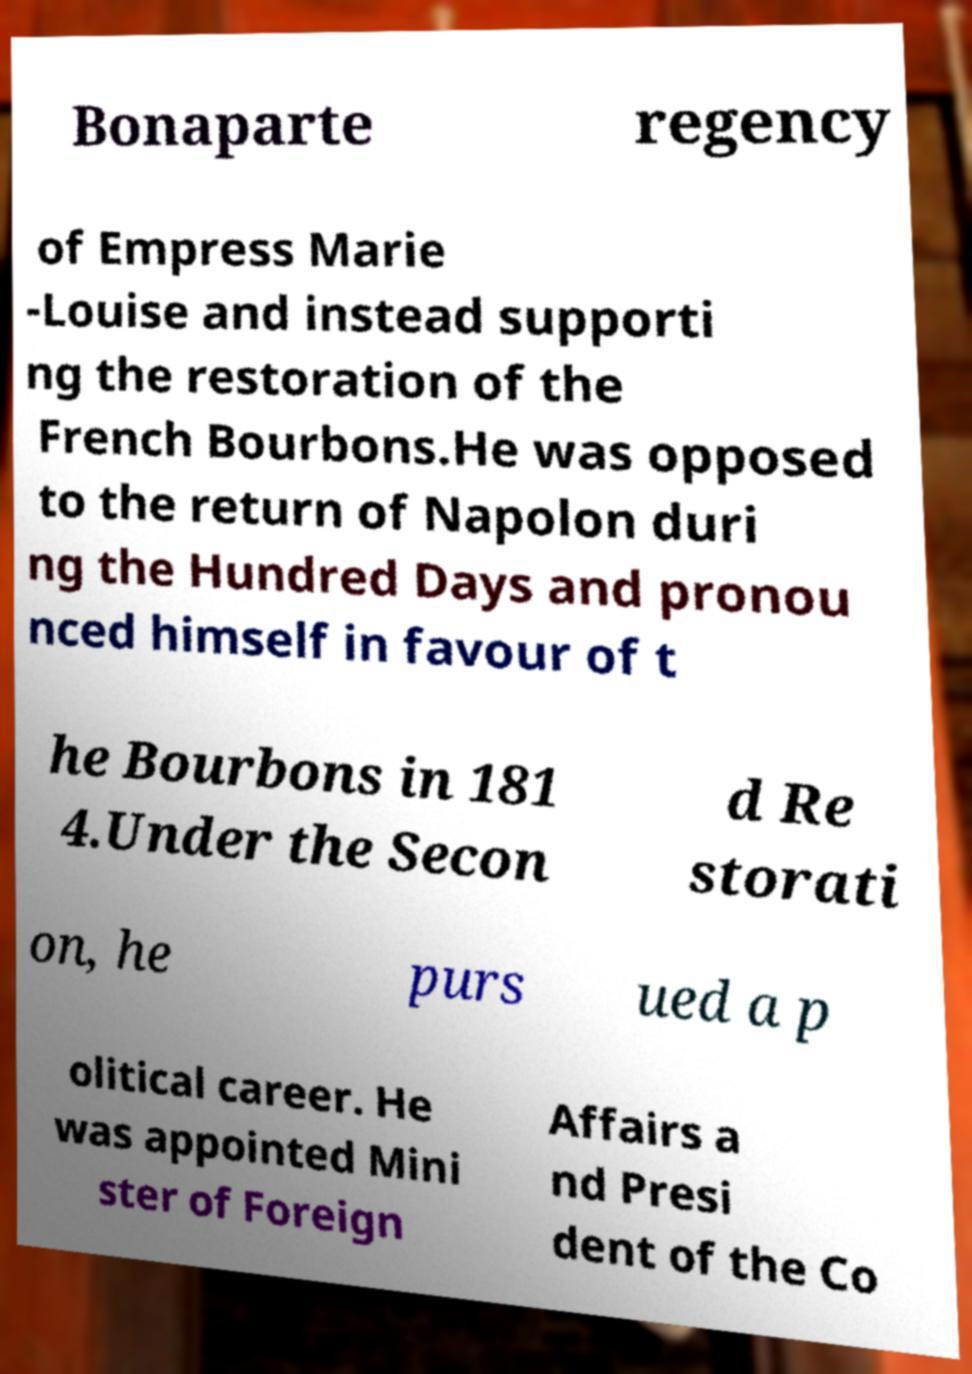What messages or text are displayed in this image? I need them in a readable, typed format. Bonaparte regency of Empress Marie -Louise and instead supporti ng the restoration of the French Bourbons.He was opposed to the return of Napolon duri ng the Hundred Days and pronou nced himself in favour of t he Bourbons in 181 4.Under the Secon d Re storati on, he purs ued a p olitical career. He was appointed Mini ster of Foreign Affairs a nd Presi dent of the Co 